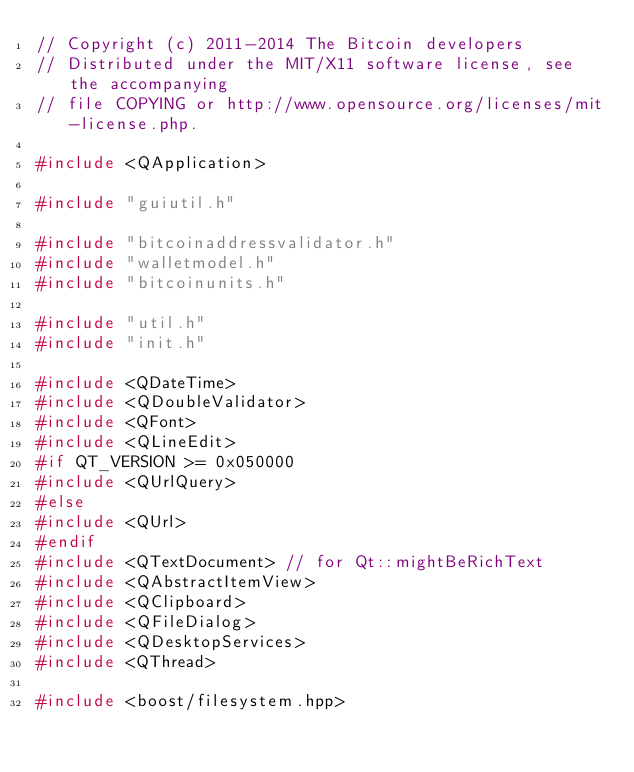Convert code to text. <code><loc_0><loc_0><loc_500><loc_500><_C++_>// Copyright (c) 2011-2014 The Bitcoin developers
// Distributed under the MIT/X11 software license, see the accompanying
// file COPYING or http://www.opensource.org/licenses/mit-license.php.

#include <QApplication>

#include "guiutil.h"

#include "bitcoinaddressvalidator.h"
#include "walletmodel.h"
#include "bitcoinunits.h"

#include "util.h"
#include "init.h"

#include <QDateTime>
#include <QDoubleValidator>
#include <QFont>
#include <QLineEdit>
#if QT_VERSION >= 0x050000
#include <QUrlQuery>
#else
#include <QUrl>
#endif
#include <QTextDocument> // for Qt::mightBeRichText
#include <QAbstractItemView>
#include <QClipboard>
#include <QFileDialog>
#include <QDesktopServices>
#include <QThread>

#include <boost/filesystem.hpp></code> 